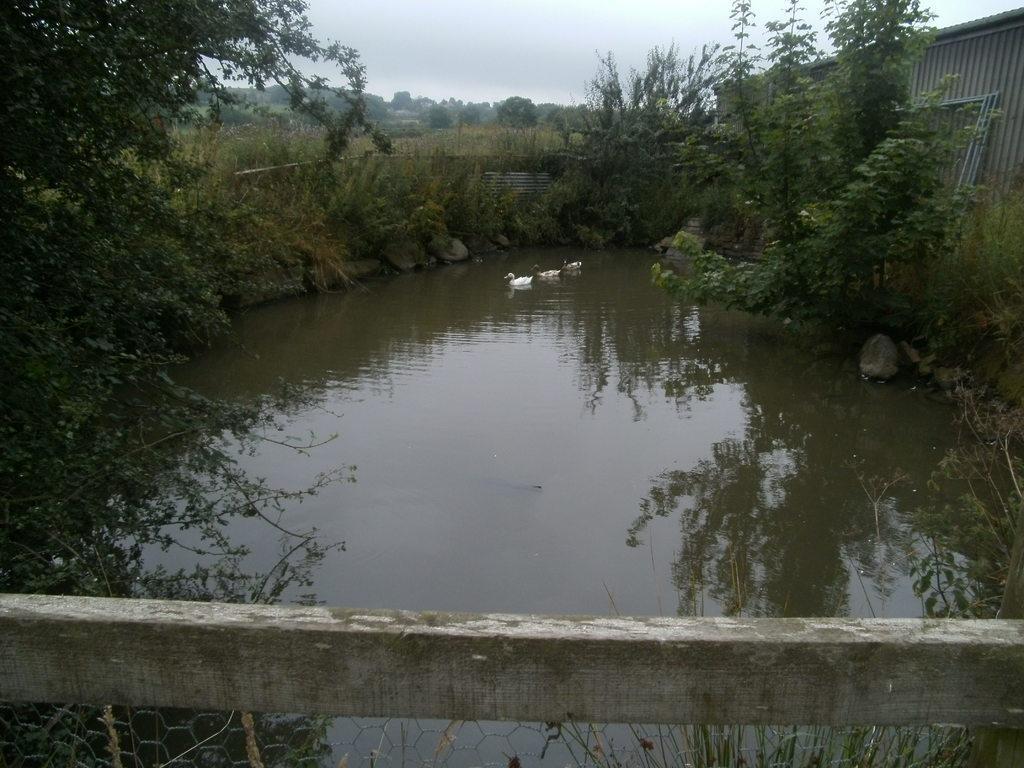In one or two sentences, can you explain what this image depicts? In this image we can see there are ducks swimming on the water, behind that there is grass and trees. 